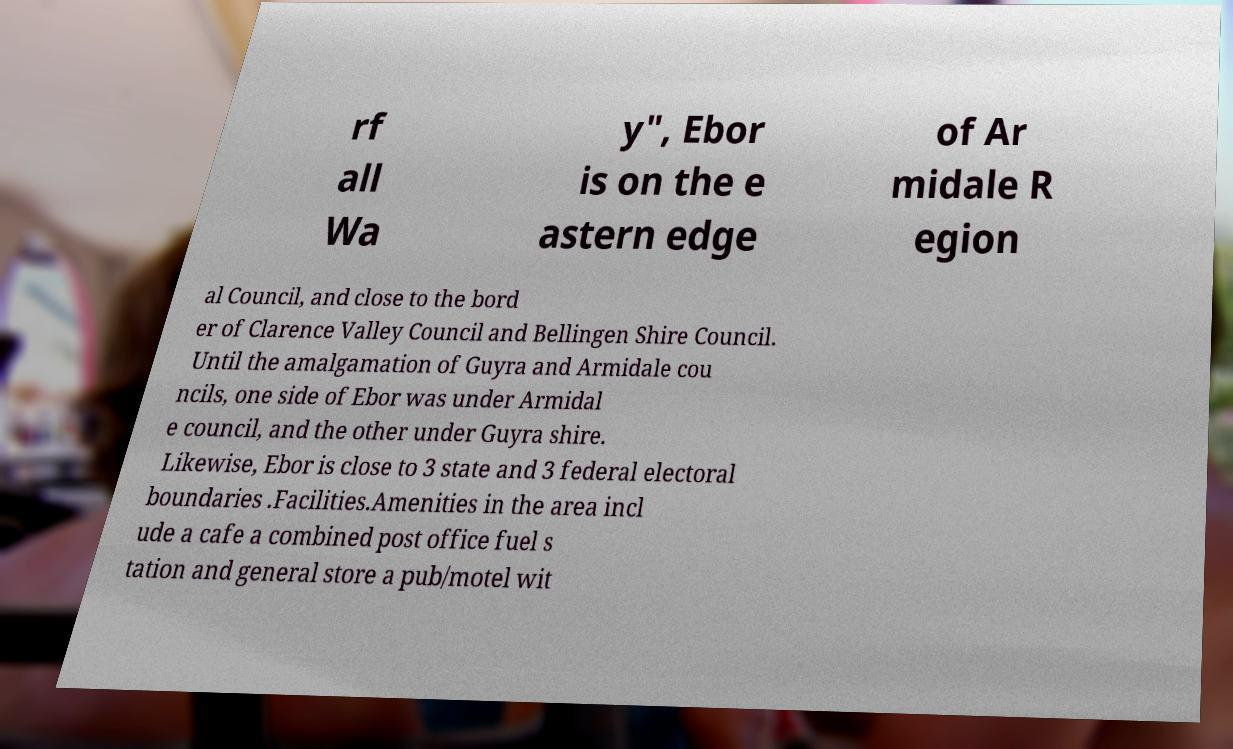Please read and relay the text visible in this image. What does it say? rf all Wa y", Ebor is on the e astern edge of Ar midale R egion al Council, and close to the bord er of Clarence Valley Council and Bellingen Shire Council. Until the amalgamation of Guyra and Armidale cou ncils, one side of Ebor was under Armidal e council, and the other under Guyra shire. Likewise, Ebor is close to 3 state and 3 federal electoral boundaries .Facilities.Amenities in the area incl ude a cafe a combined post office fuel s tation and general store a pub/motel wit 